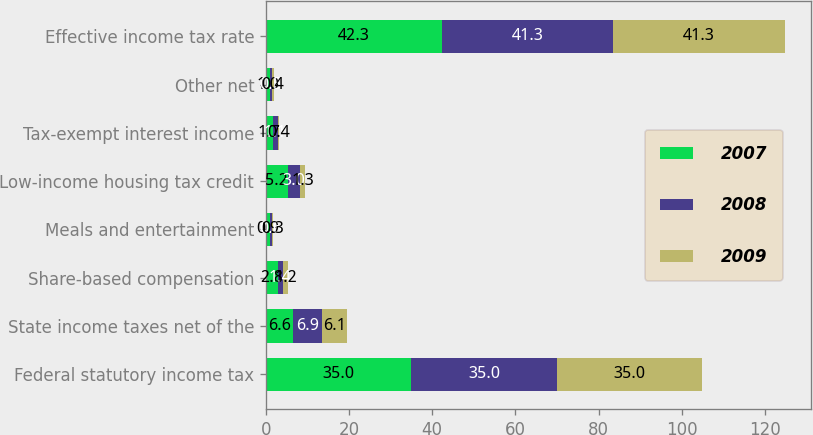Convert chart to OTSL. <chart><loc_0><loc_0><loc_500><loc_500><stacked_bar_chart><ecel><fcel>Federal statutory income tax<fcel>State income taxes net of the<fcel>Share-based compensation<fcel>Meals and entertainment<fcel>Low-income housing tax credit<fcel>Tax-exempt interest income<fcel>Other net<fcel>Effective income tax rate<nl><fcel>2007<fcel>35<fcel>6.6<fcel>2.8<fcel>0.9<fcel>5.2<fcel>1.7<fcel>1<fcel>42.3<nl><fcel>2008<fcel>35<fcel>6.9<fcel>1.4<fcel>0.6<fcel>3<fcel>1.1<fcel>0.5<fcel>41.3<nl><fcel>2009<fcel>35<fcel>6.1<fcel>1.2<fcel>0.3<fcel>1.3<fcel>0.4<fcel>0.4<fcel>41.3<nl></chart> 